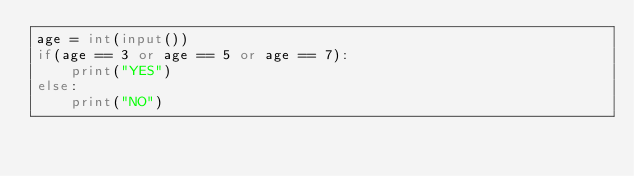Convert code to text. <code><loc_0><loc_0><loc_500><loc_500><_Python_>age = int(input())
if(age == 3 or age == 5 or age == 7):
    print("YES")
else:
    print("NO")</code> 